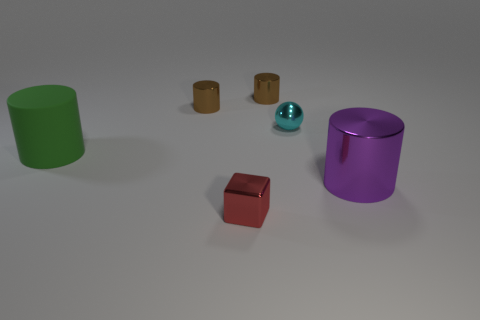What could be the function of the blue spherical object? The blue spherical object resembles a ball and could serve as a decorative element or as a part of some game. Its reflective surface adds an interesting visual effect to the setting. Is there any object that could serve as a container for the others? The purple object appears to be a container with an open top; hence, it could potentially hold the other items, particularly the brown cylinders or the blue ball. 